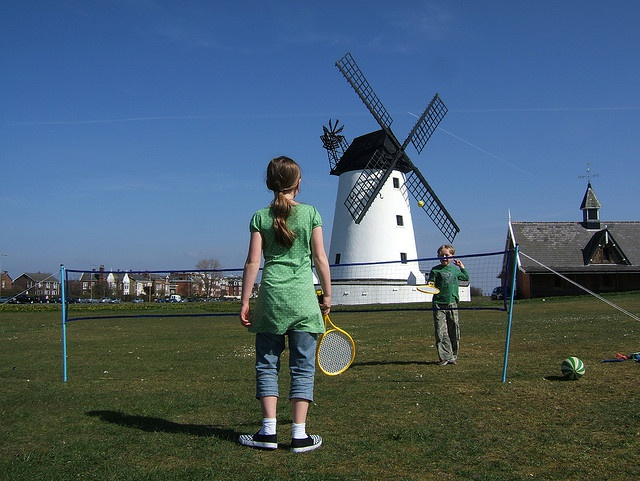Describe the objects in this image and their specific colors. I can see people in blue, black, gray, and green tones, people in blue, black, gray, teal, and darkgray tones, tennis racket in blue, darkgray, gray, olive, and black tones, sports ball in blue, black, darkgreen, and darkgray tones, and car in blue, black, navy, gray, and darkblue tones in this image. 